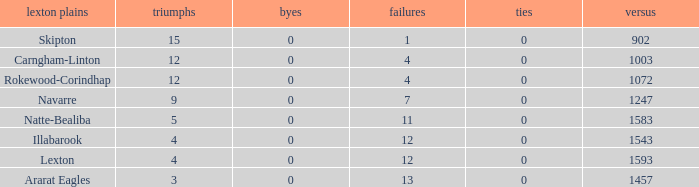What is the most wins with 0 byes? None. 